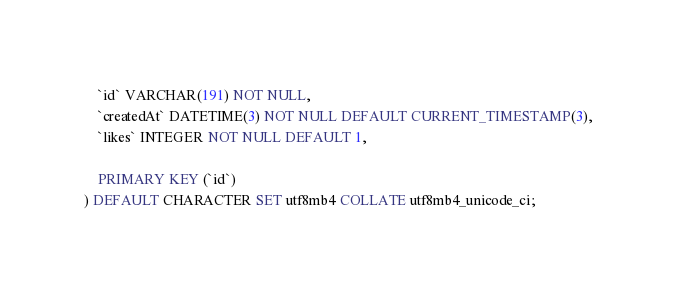<code> <loc_0><loc_0><loc_500><loc_500><_SQL_>    `id` VARCHAR(191) NOT NULL,
    `createdAt` DATETIME(3) NOT NULL DEFAULT CURRENT_TIMESTAMP(3),
    `likes` INTEGER NOT NULL DEFAULT 1,

    PRIMARY KEY (`id`)
) DEFAULT CHARACTER SET utf8mb4 COLLATE utf8mb4_unicode_ci;
</code> 